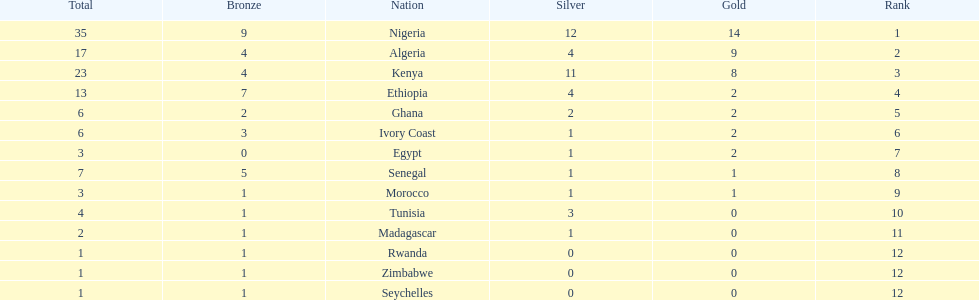The squad before algeria Nigeria. 